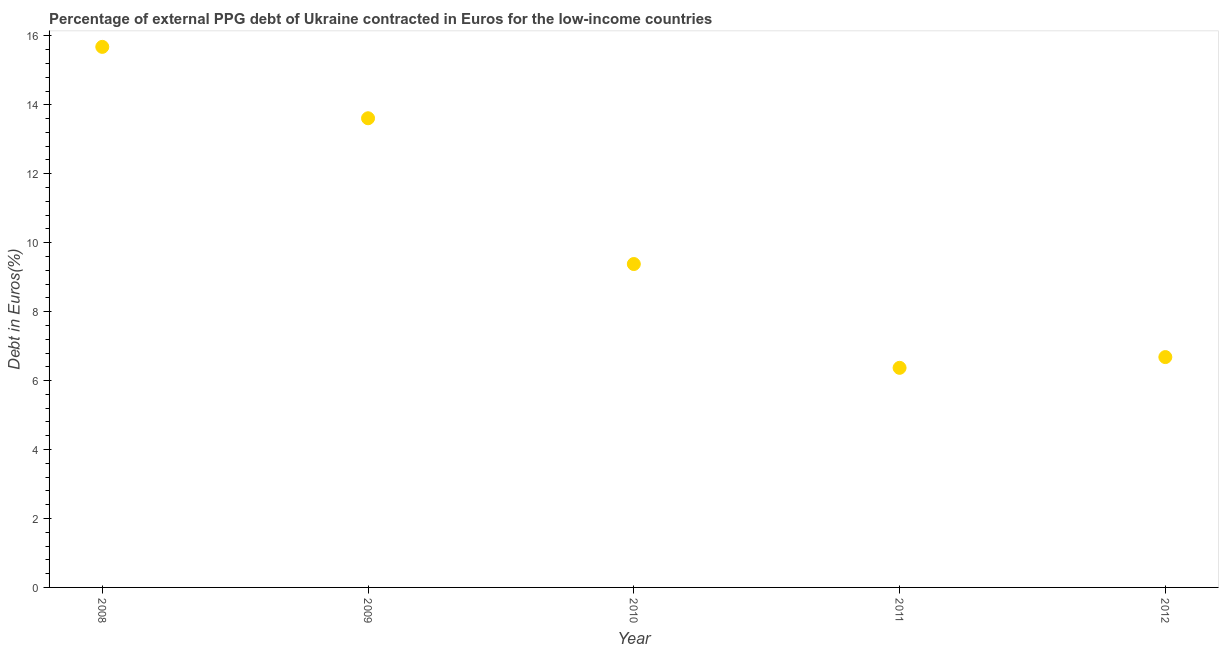What is the currency composition of ppg debt in 2012?
Keep it short and to the point. 6.68. Across all years, what is the maximum currency composition of ppg debt?
Offer a terse response. 15.68. Across all years, what is the minimum currency composition of ppg debt?
Keep it short and to the point. 6.37. In which year was the currency composition of ppg debt maximum?
Make the answer very short. 2008. What is the sum of the currency composition of ppg debt?
Provide a short and direct response. 51.73. What is the difference between the currency composition of ppg debt in 2008 and 2010?
Offer a terse response. 6.3. What is the average currency composition of ppg debt per year?
Your response must be concise. 10.35. What is the median currency composition of ppg debt?
Your answer should be compact. 9.38. In how many years, is the currency composition of ppg debt greater than 4 %?
Your response must be concise. 5. Do a majority of the years between 2012 and 2008 (inclusive) have currency composition of ppg debt greater than 9.2 %?
Your answer should be compact. Yes. What is the ratio of the currency composition of ppg debt in 2010 to that in 2012?
Your answer should be compact. 1.4. What is the difference between the highest and the second highest currency composition of ppg debt?
Your answer should be very brief. 2.07. What is the difference between the highest and the lowest currency composition of ppg debt?
Keep it short and to the point. 9.31. In how many years, is the currency composition of ppg debt greater than the average currency composition of ppg debt taken over all years?
Give a very brief answer. 2. What is the difference between two consecutive major ticks on the Y-axis?
Offer a very short reply. 2. Are the values on the major ticks of Y-axis written in scientific E-notation?
Your answer should be very brief. No. Does the graph contain any zero values?
Keep it short and to the point. No. Does the graph contain grids?
Provide a short and direct response. No. What is the title of the graph?
Your response must be concise. Percentage of external PPG debt of Ukraine contracted in Euros for the low-income countries. What is the label or title of the X-axis?
Provide a short and direct response. Year. What is the label or title of the Y-axis?
Provide a short and direct response. Debt in Euros(%). What is the Debt in Euros(%) in 2008?
Ensure brevity in your answer.  15.68. What is the Debt in Euros(%) in 2009?
Your answer should be very brief. 13.61. What is the Debt in Euros(%) in 2010?
Make the answer very short. 9.38. What is the Debt in Euros(%) in 2011?
Offer a very short reply. 6.37. What is the Debt in Euros(%) in 2012?
Keep it short and to the point. 6.68. What is the difference between the Debt in Euros(%) in 2008 and 2009?
Ensure brevity in your answer.  2.07. What is the difference between the Debt in Euros(%) in 2008 and 2010?
Make the answer very short. 6.3. What is the difference between the Debt in Euros(%) in 2008 and 2011?
Provide a short and direct response. 9.31. What is the difference between the Debt in Euros(%) in 2008 and 2012?
Your response must be concise. 9. What is the difference between the Debt in Euros(%) in 2009 and 2010?
Provide a short and direct response. 4.23. What is the difference between the Debt in Euros(%) in 2009 and 2011?
Make the answer very short. 7.24. What is the difference between the Debt in Euros(%) in 2009 and 2012?
Provide a succinct answer. 6.93. What is the difference between the Debt in Euros(%) in 2010 and 2011?
Give a very brief answer. 3.01. What is the difference between the Debt in Euros(%) in 2010 and 2012?
Your answer should be very brief. 2.7. What is the difference between the Debt in Euros(%) in 2011 and 2012?
Your answer should be very brief. -0.31. What is the ratio of the Debt in Euros(%) in 2008 to that in 2009?
Make the answer very short. 1.15. What is the ratio of the Debt in Euros(%) in 2008 to that in 2010?
Keep it short and to the point. 1.67. What is the ratio of the Debt in Euros(%) in 2008 to that in 2011?
Offer a terse response. 2.46. What is the ratio of the Debt in Euros(%) in 2008 to that in 2012?
Make the answer very short. 2.35. What is the ratio of the Debt in Euros(%) in 2009 to that in 2010?
Provide a succinct answer. 1.45. What is the ratio of the Debt in Euros(%) in 2009 to that in 2011?
Ensure brevity in your answer.  2.14. What is the ratio of the Debt in Euros(%) in 2009 to that in 2012?
Give a very brief answer. 2.04. What is the ratio of the Debt in Euros(%) in 2010 to that in 2011?
Make the answer very short. 1.47. What is the ratio of the Debt in Euros(%) in 2010 to that in 2012?
Your response must be concise. 1.4. What is the ratio of the Debt in Euros(%) in 2011 to that in 2012?
Provide a succinct answer. 0.95. 